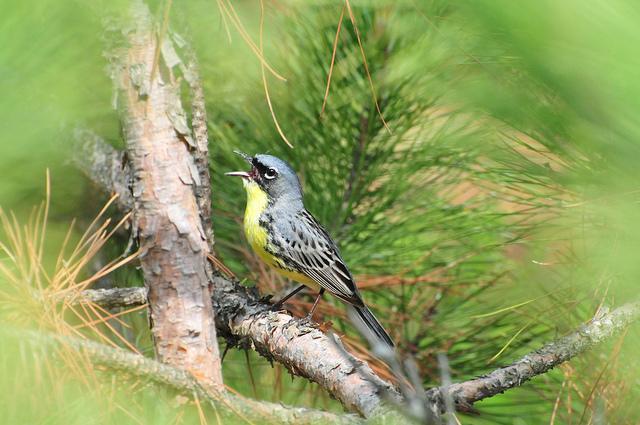How many birds are pictured?
Give a very brief answer. 1. 